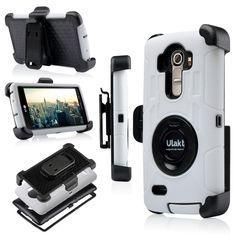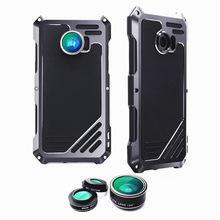The first image is the image on the left, the second image is the image on the right. For the images shown, is this caption "One image shows a group of five items showing configurations of a device that is black and one other color, and the other image shows a rectangular device in two side-by-side views." true? Answer yes or no. Yes. 